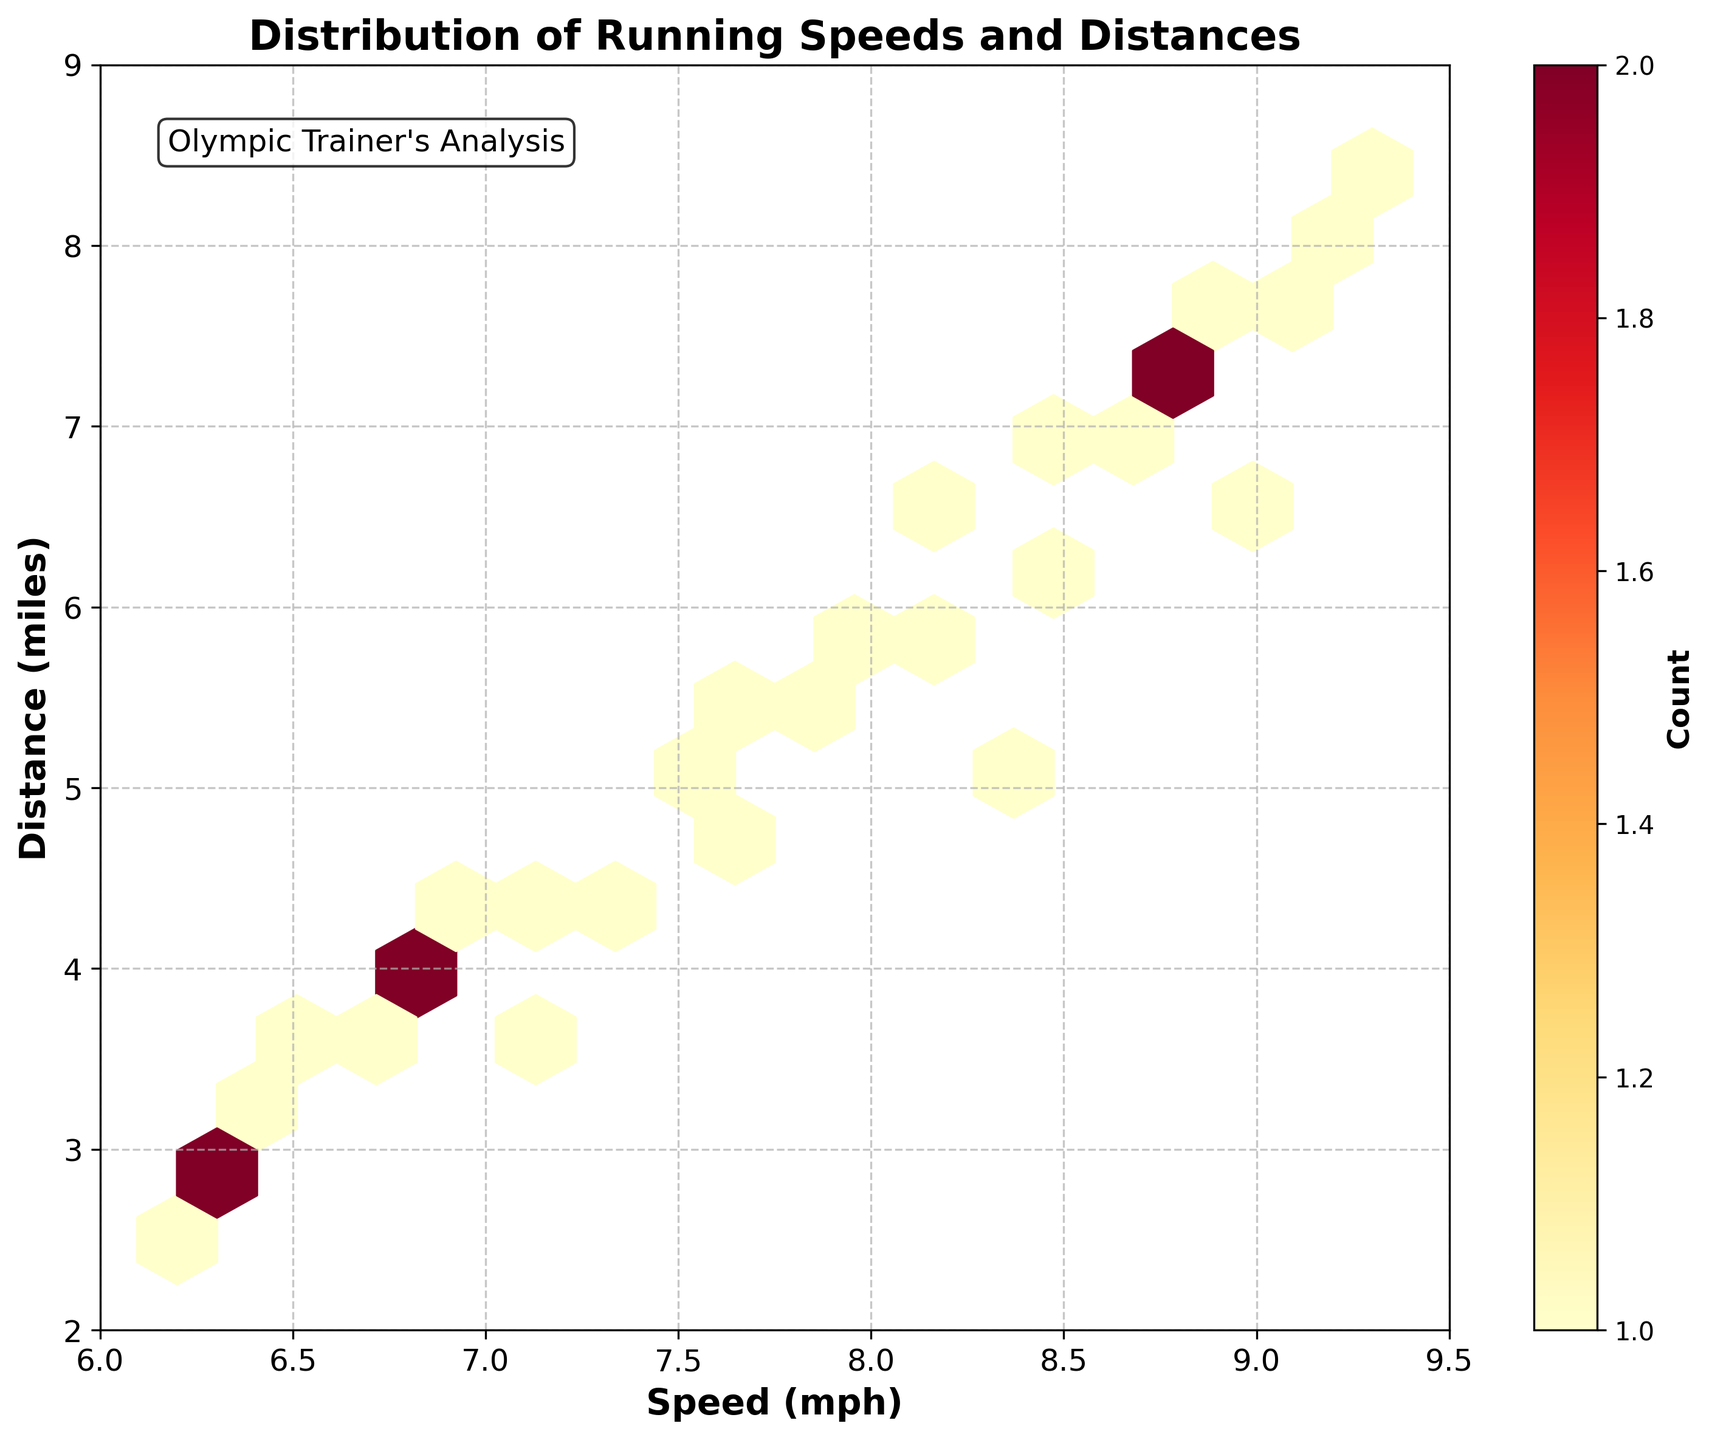What is the title of the hexbin plot? The title of the plot is written at the top of the figure to describe what the plot is showing. It reads "Distribution of Running Speeds and Distances."
Answer: Distribution of Running Speeds and Distances What do the x-axis and y-axis represent in this hexbin plot? The labels on the x-axis and y-axis indicate the variables being plotted. The x-axis is labeled "Speed (mph)" and the y-axis is labeled "Distance (miles)."
Answer: Speed (mph) and Distance (miles) What does the color intensity in the hexbin plot indicate? The color intensity in the hexbin plot, which ranges from yellow to red, indicates the count of data points within each hexbin. Darker colors represent higher counts. This is further explained by the color bar on the right with the label "Count."
Answer: Count of data points Where is the count of data points the highest? The highest count of data points is represented by the darkest hexes in the plot. The darkest hexes are located around the speed of approximately 7.0 to 7.5 mph and distance of about 4.0 to 5.0 miles.
Answer: Around 7.0 to 7.5 mph and 4.0 to 5.0 miles What is the range of speeds indicated on the x-axis? The x-axis ranges from 6 to 9.5 mph, which can be seen by looking at the limits set for the axis underneath the plot.
Answer: 6 to 9.5 mph What is the average speed of the training sessions if the hexbin plot indicates clusters at certain speeds? The plot shows frequent clusters around speeds of 7.0 to 8.0 mph. To find the average speed, one can visually estimate based on the densest regions. Summarizing these regions gives an average around 7.5 mph.
Answer: About 7.5 mph In which speed and distance range is there almost no data? The plot shows sparse or no data in the regions with the lightest color or no hexes. This is observed towards the highest end of both axes, above approximately 9.0 mph and above 8.0 miles.
Answer: Above 9.0 mph and 8.0 miles What additional information does the text box on the plot provide? The text box in the top-left corner of the plot contains "Olympic Trainer's Analysis," indicating the source or perspective of the analysis.
Answer: Olympic Trainer's Analysis Can you compare the density of runs between speeds of 6.0-7.0 mph and 8.0-9.0 mph? The density of runs in the range of 6.0-7.0 mph is lower, as indicated by fewer and lighter-colored hexes compared to the range of 8.0-9.0 mph, which has more and darker-colored hexes.
Answer: 8.0-9.0 mph has higher density What is the grid size used in this hexbin plot? The grid size refers to the number of hexagonal bins used to segment the data points on the plot. It can be identified by the documentation or detailed analysis of the plot’s structure. The grid size used here is 15.
Answer: 15 